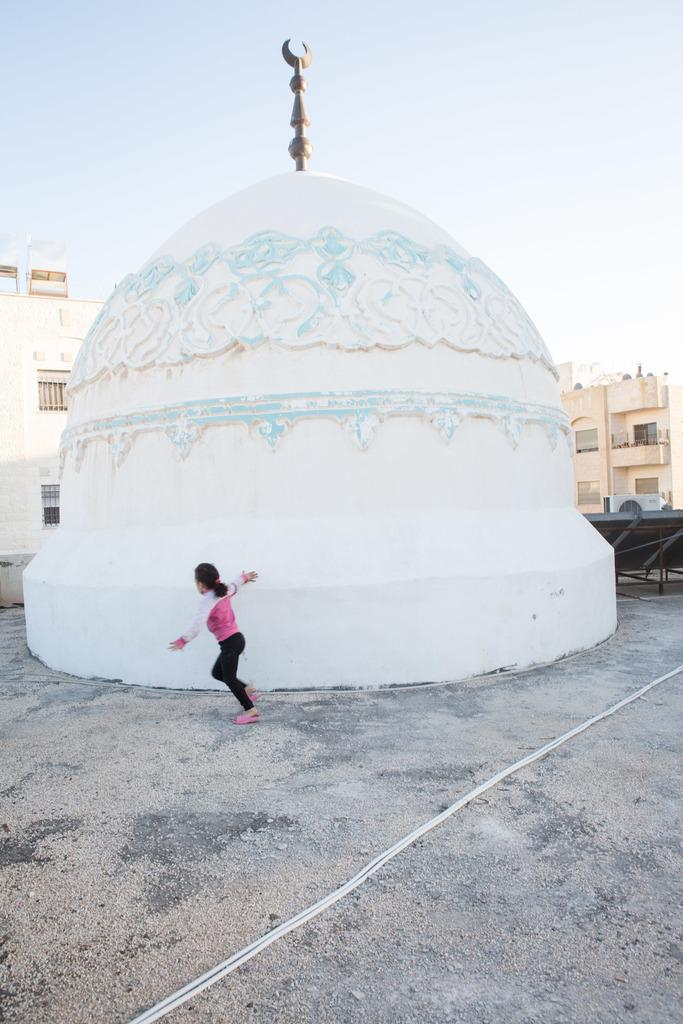What can be seen in the image? There is a person in the image. What is the person wearing? The person is wearing a pink shirt and black pants. What is visible in the background of the image? There are buildings and the sky in the background of the image. What color are the buildings in the image? The buildings are in cream color. What color is the sky in the image? The sky is in white color. What type of rhythm is the person dancing to in the image? There is no indication in the image that the person is dancing, so it is not possible to determine the type of rhythm they might be dancing to. 